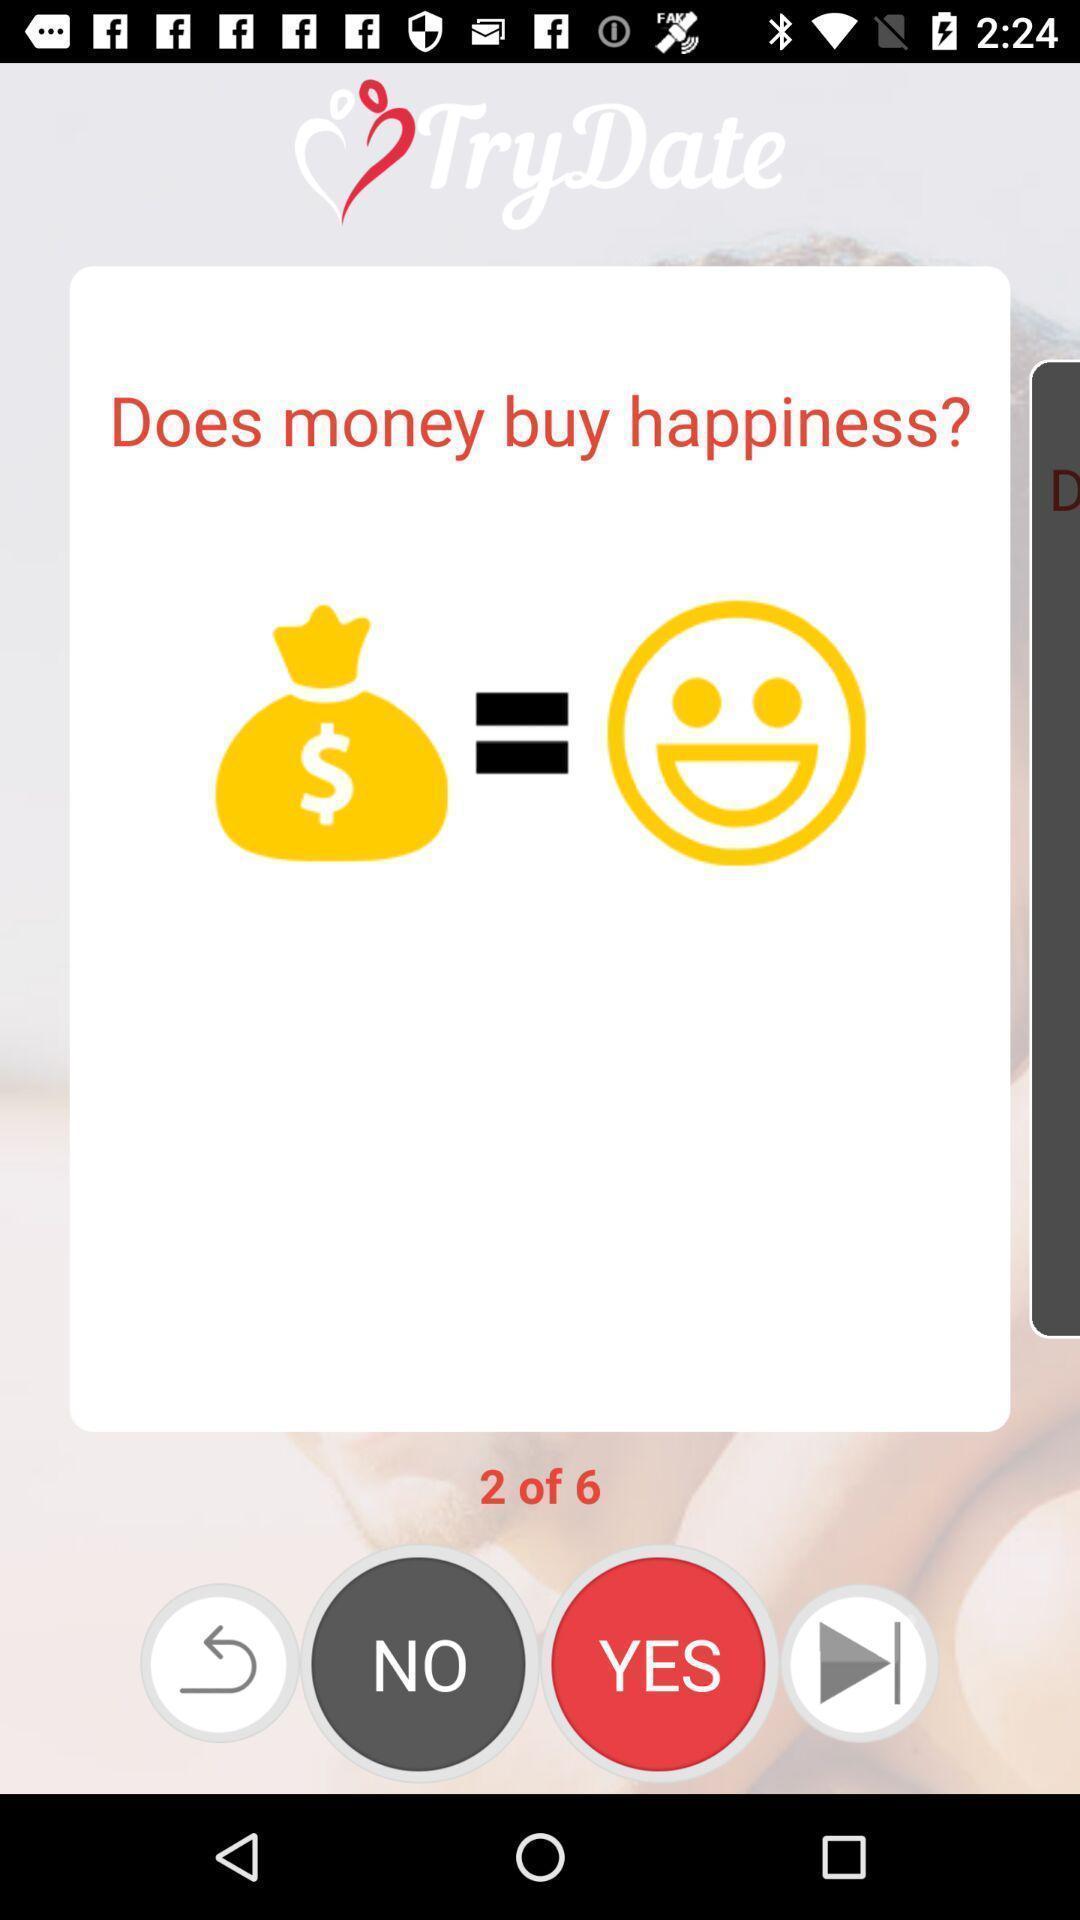Tell me about the visual elements in this screen capture. Page showing pop-up to continue. 